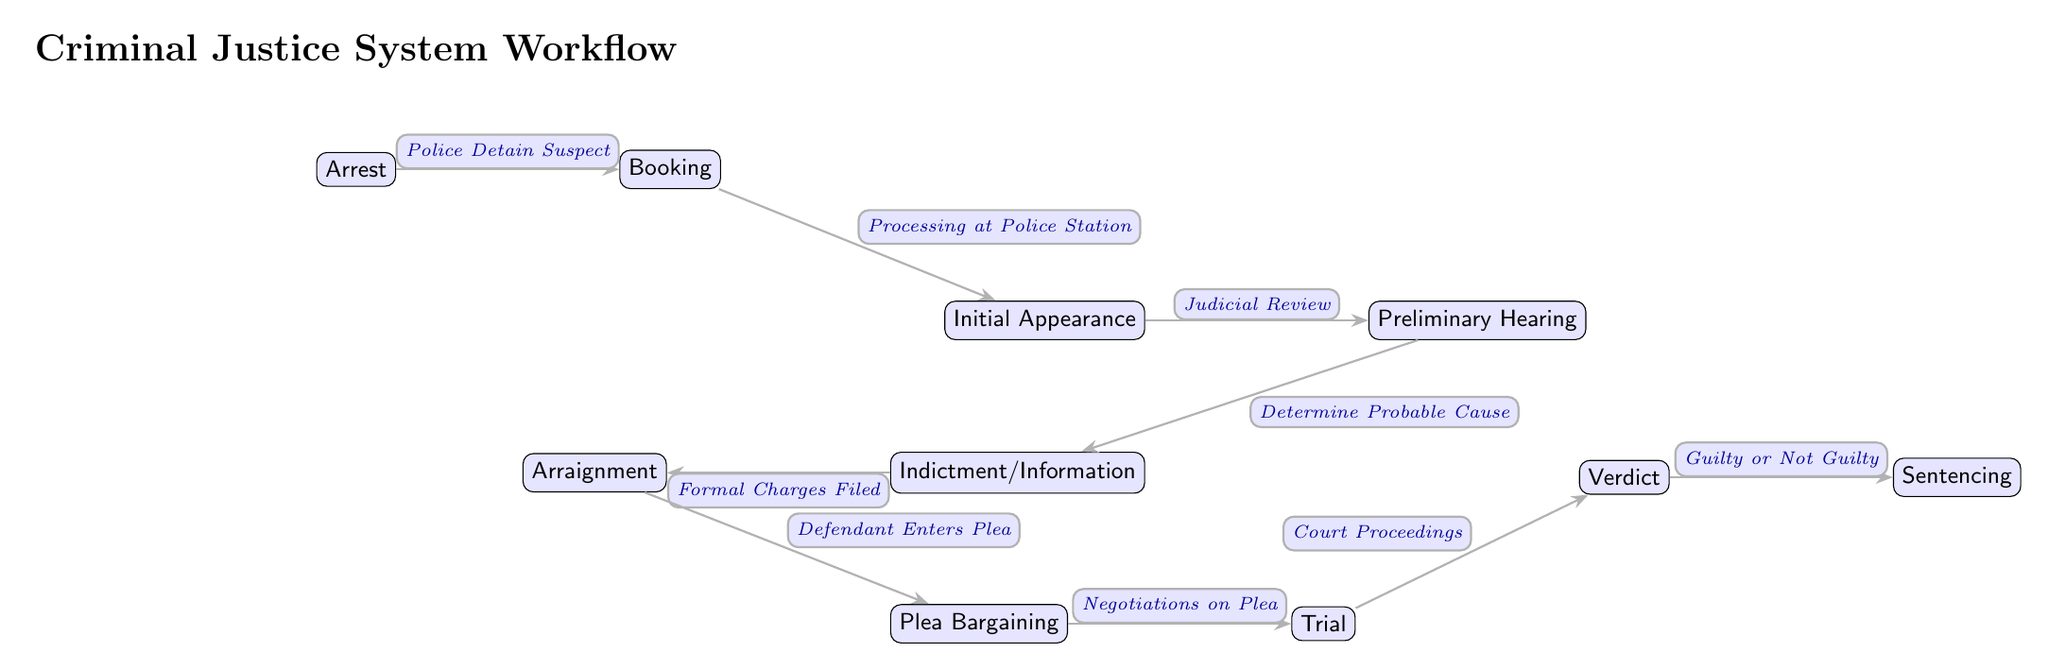What is the first step in the workflow? The diagram shows "Arrest" as the first node in the workflow sequence, indicating it is the initial step in the criminal justice system process.
Answer: Arrest How many nodes are there in the workflow? By counting each distinct step represented as a node in the diagram, we find there are a total of 10 nodes.
Answer: 10 What follows the "Initial Appearance"? The arrow from "Initial Appearance" leads to "Preliminary Hearing", showing that this is the next step in the workflow after the initial appearance of the suspect in court.
Answer: Preliminary Hearing What is the role of "Plea Bargaining" in the workflow? The diagram indicates that "Plea Bargaining" occurs after the "Arraignment", where the defendant may negotiate a plea. This shows it is a critical phase in determining how the case may be resolved before going to trial.
Answer: Negotiations on Plea Which node concludes the workflow? The last node in the diagram is "Sentencing", representing the final outcome after a verdict is reached. This indicates the completion of the process overall.
Answer: Sentencing What action is taken during the "Preliminary Hearing"? The diagram specifies that during the "Preliminary Hearing", the action taken is to "Determine Probable Cause", indicating a judicial review step ensuring there is sufficient evidence to proceed.
Answer: Determine Probable Cause What happens after the "Trial"? According to the diagram, after the "Trial" stage, the next node is "Verdict", which indicates that the trial concludes with the court reaching a decision on the case.
Answer: Verdict What type of plea is entered during "Arraignment"? The diagram indicates that during "Arraignment", the "Defendant Enters Plea", which typically means the plea could be guilty, not guilty, or no contest, reflecting the defendant's response to the charges.
Answer: Defendant Enters Plea What is the relationship between "Indictment/Information" and "Arraignment"? The diagram shows a directional edge from "Indictment/Information" to "Arraignment", indicating that formal charges are filed during the indictment stage, which leads directly to the arraignment process.
Answer: Formal Charges Filed 